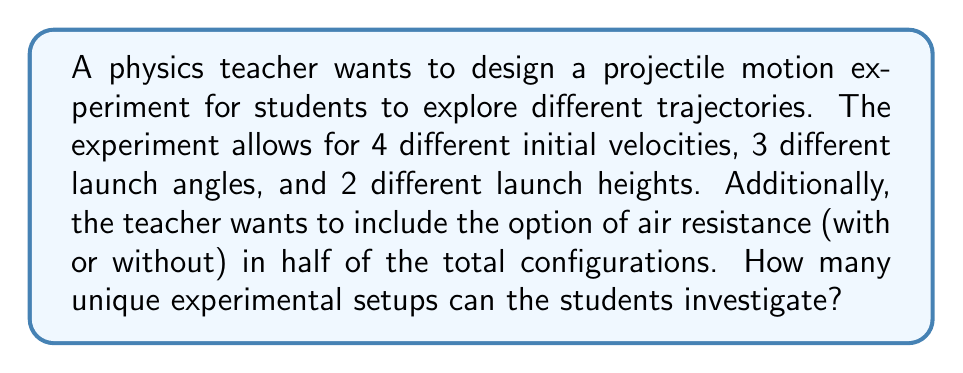Help me with this question. Let's break this problem down step by step:

1) First, let's consider the number of combinations without air resistance:

   - Initial velocities: 4 options
   - Launch angles: 3 options
   - Launch heights: 2 options

   Using the multiplication principle, we have:
   $$ 4 \times 3 \times 2 = 24 $$

2) Now, the question states that the air resistance option (with or without) should be included in half of the total configurations. This means we need to double our current number:

   $$ 24 \times 2 = 48 $$

3) This can be thought of as a combination problem where we're selecting which half of the configurations will include air resistance. However, since the question asks for the total number of unique setups, we don't need to calculate this combination.

4) Each of these 48 configurations represents a unique experimental setup that students can investigate, as each combination of initial velocity, launch angle, launch height, and presence/absence of air resistance will result in a different trajectory.

This approach aligns with the curriculum specialist's goal of integrating physics and mathematics, as it combines the physical concepts of projectile motion with the mathematical principle of counting and permutations.
Answer: 48 unique experimental setups 